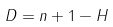<formula> <loc_0><loc_0><loc_500><loc_500>D = n + 1 - H</formula> 